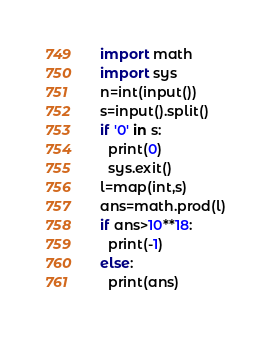Convert code to text. <code><loc_0><loc_0><loc_500><loc_500><_Python_>import math
import sys
n=int(input())
s=input().split()
if '0' in s:
  print(0)
  sys.exit()
l=map(int,s)
ans=math.prod(l)
if ans>10**18:
  print(-1)
else:
  print(ans)</code> 